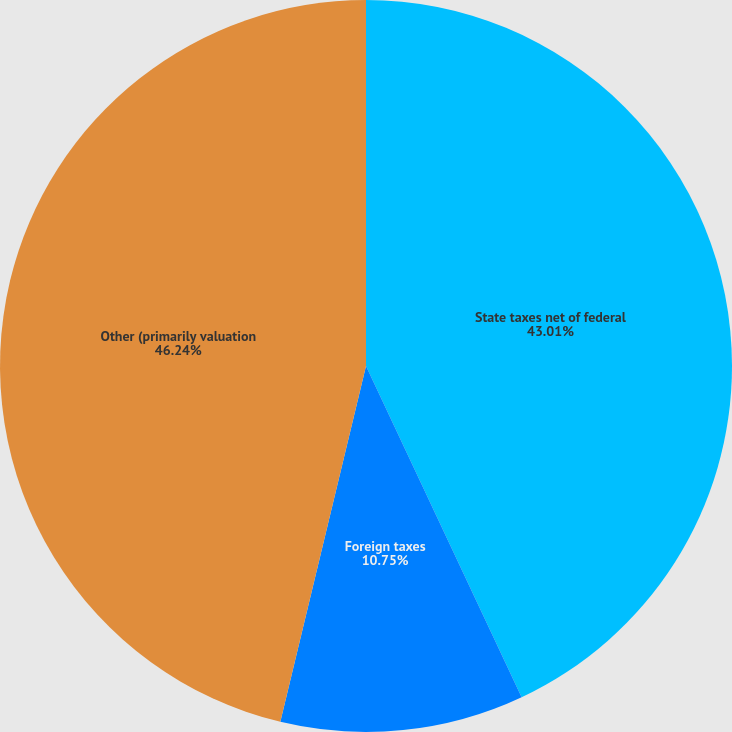Convert chart. <chart><loc_0><loc_0><loc_500><loc_500><pie_chart><fcel>State taxes net of federal<fcel>Foreign taxes<fcel>Other (primarily valuation<nl><fcel>43.01%<fcel>10.75%<fcel>46.24%<nl></chart> 